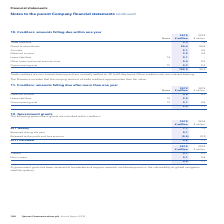According to Spirent Communications Plc's financial document, What was the government grant received for? to accelerate and support research and development in the vulnerability of global navigation satellite systems. The document states: "A government grant has been received to accelerate and support research and development in the vulnerability of global navigation satellite systems...." Also, What was the amount of Current government grants in 2019? According to the financial document, 0.7 (in millions). The relevant text states: "Current 0.7 0.3..." Also, What are the types of government grants included within creditors? The document shows two values: Current and Non-current. From the document: "Non-current 0.1 0.8 Non-current 0.1 0.8..." Additionally, In which year was the amount of current government grants larger? According to the financial document, 2019. The relevant text states: "180 Spirent Communications plc Annual Report 2019..." Also, can you calculate: What was the change in the amount of current government grants? Based on the calculation: 0.7-0.3, the result is 0.4 (in millions). This is based on the information: "Current 0.7 0.3 Current 0.7 0.3..." The key data points involved are: 0.3, 0.7. Also, can you calculate: What was the percentage change in the amount of current government grants? To answer this question, I need to perform calculations using the financial data. The calculation is: (0.7-0.3)/0.3, which equals 133.33 (percentage). This is based on the information: "Current 0.7 0.3 Current 0.7 0.3..." The key data points involved are: 0.3, 0.7. 